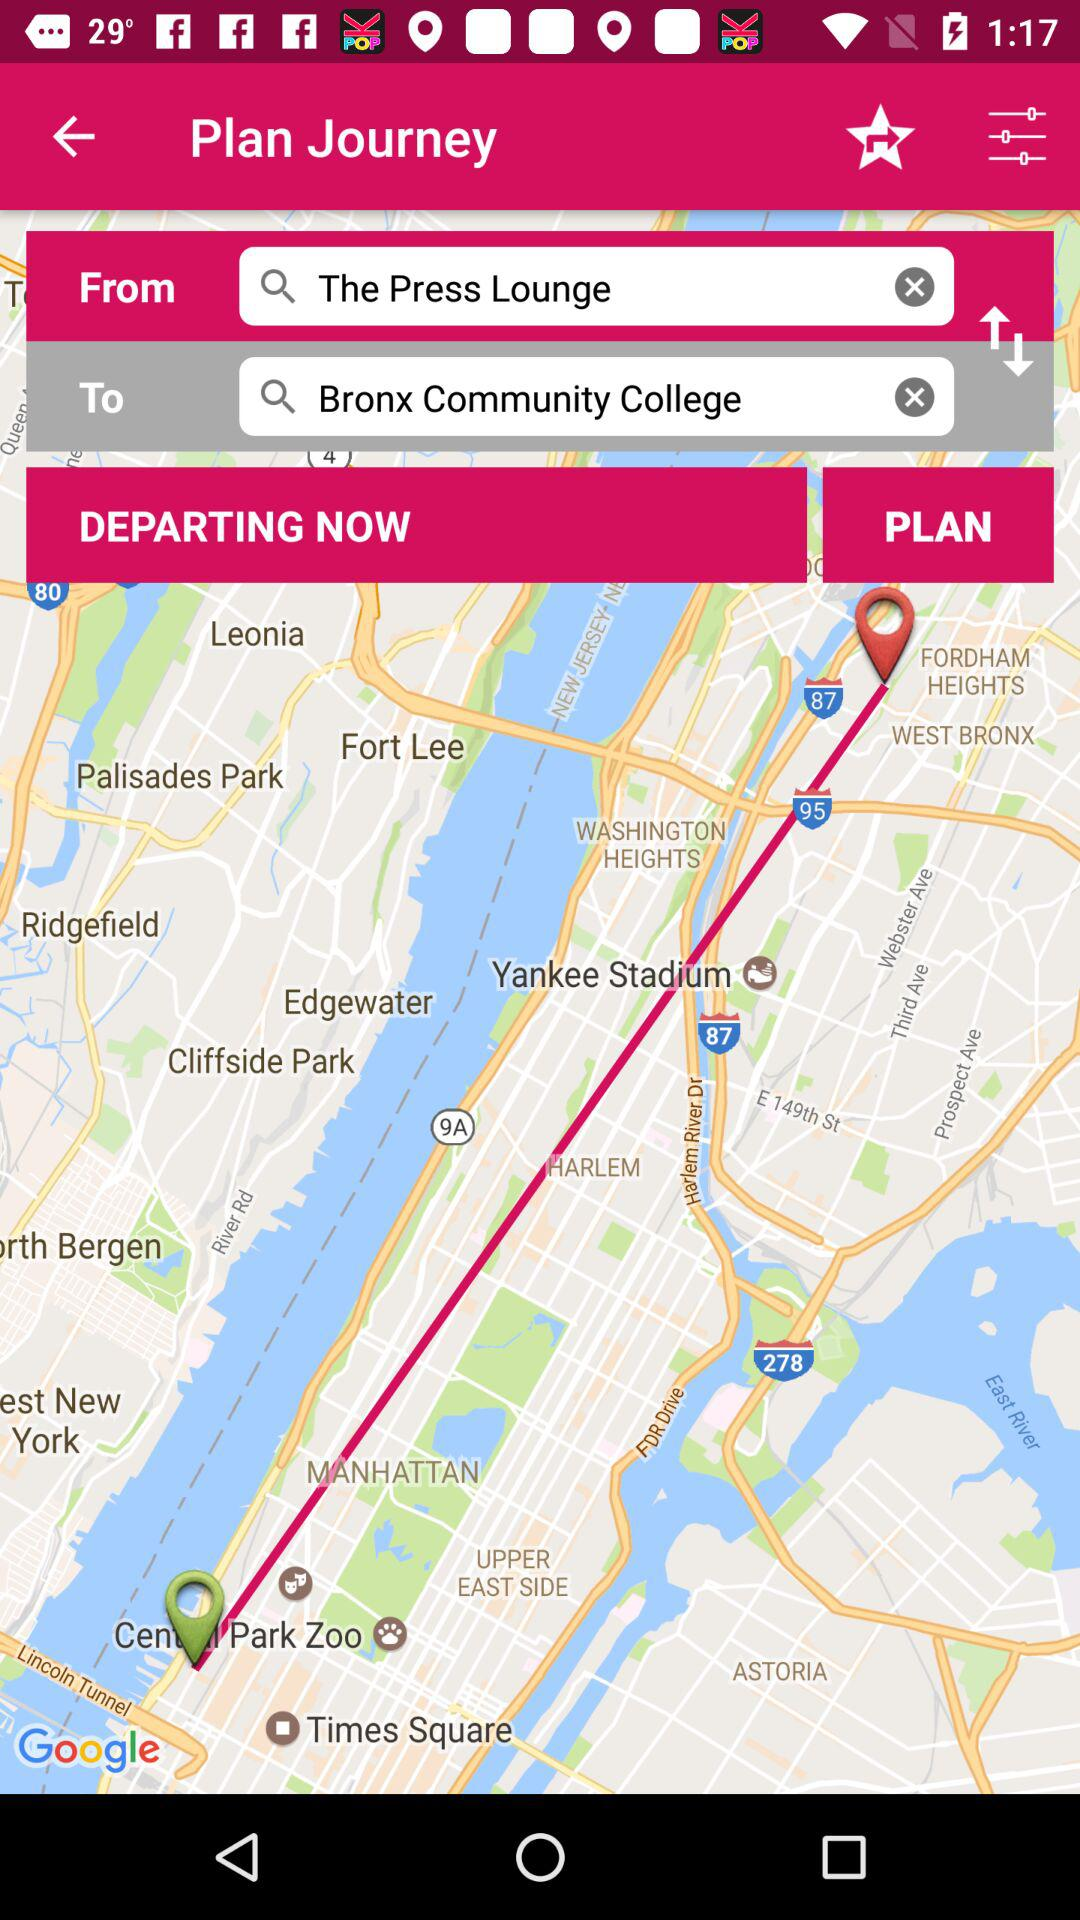What is the arrival location? The arrival location is "Bronx Community College". 